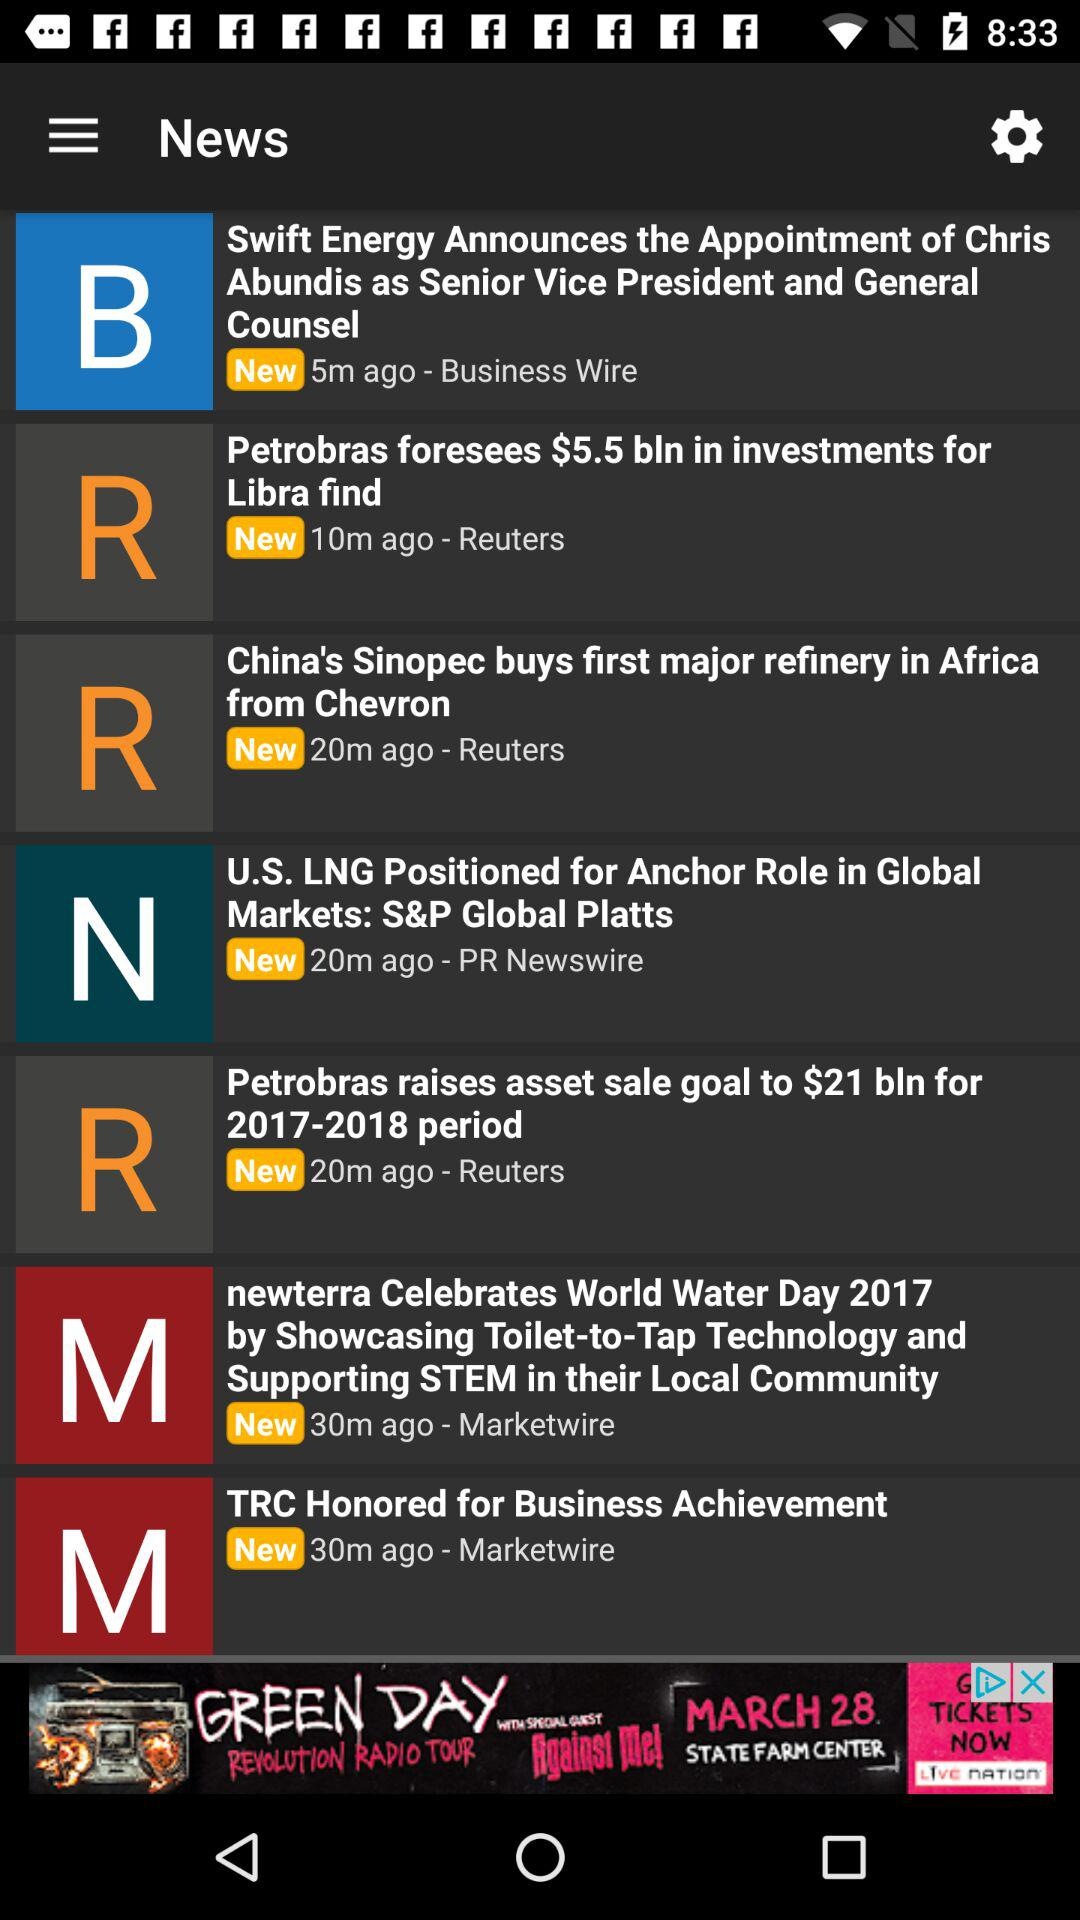On what day was "TRC Honored for Business Achievement" published?
When the provided information is insufficient, respond with <no answer>. <no answer> 